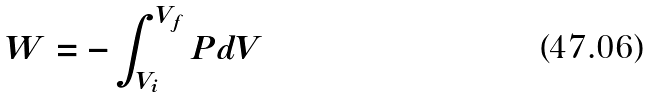Convert formula to latex. <formula><loc_0><loc_0><loc_500><loc_500>W = - \int _ { V _ { i } } ^ { V _ { f } } P d V</formula> 